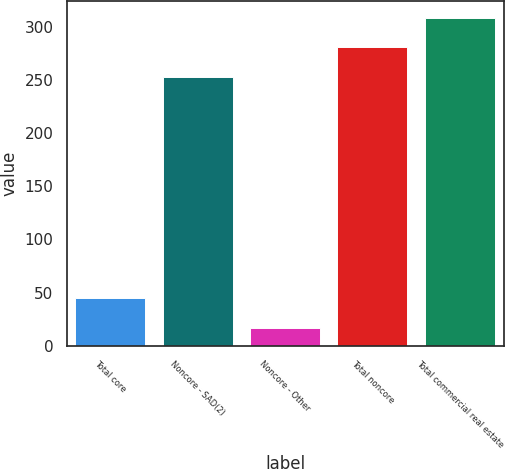Convert chart. <chart><loc_0><loc_0><loc_500><loc_500><bar_chart><fcel>Total core<fcel>Noncore - SAD(2)<fcel>Noncore - Other<fcel>Total noncore<fcel>Total commercial real estate<nl><fcel>44.8<fcel>253<fcel>17<fcel>280.8<fcel>308.6<nl></chart> 